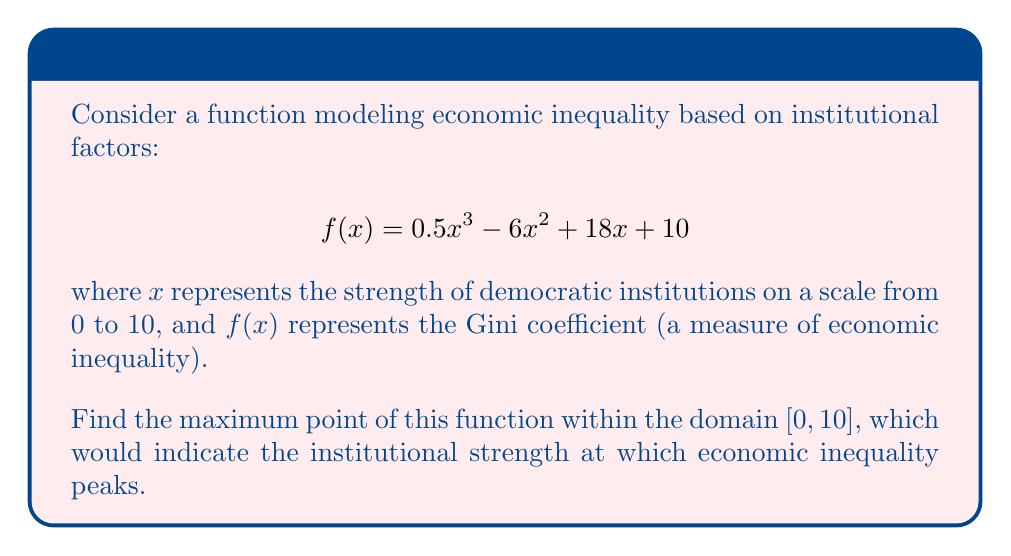Can you solve this math problem? To find the maximum point of the function, we need to follow these steps:

1) First, find the critical points by taking the derivative and setting it equal to zero:

   $$f'(x) = 1.5x^2 - 12x + 18$$
   $$1.5x^2 - 12x + 18 = 0$$

2) Solve this quadratic equation:
   
   $$a = 1.5, b = -12, c = 18$$
   $$x = \frac{-b \pm \sqrt{b^2 - 4ac}}{2a}$$
   $$x = \frac{12 \pm \sqrt{144 - 108}}{3} = \frac{12 \pm 6}{3}$$

3) This gives us two critical points:
   
   $$x_1 = \frac{12 + 6}{3} = 6$$
   $$x_2 = \frac{12 - 6}{3} = 2$$

4) We also need to consider the endpoints of our domain [0, 10].

5) Now, evaluate f(x) at these four points:

   $$f(0) = 10$$
   $$f(2) = 0.5(2)^3 - 6(2)^2 + 18(2) + 10 = 22$$
   $$f(6) = 0.5(6)^3 - 6(6)^2 + 18(6) + 10 = 46$$
   $$f(10) = 0.5(10)^3 - 6(10)^2 + 18(10) + 10 = 190$$

6) The maximum value occurs at x = 10, which is at the upper bound of our domain.

Therefore, the maximum point is (10, 190).
Answer: (10, 190) 